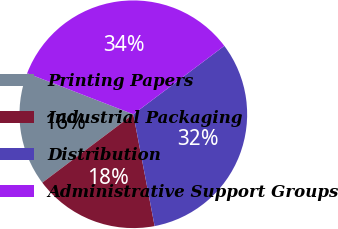Convert chart to OTSL. <chart><loc_0><loc_0><loc_500><loc_500><pie_chart><fcel>Printing Papers<fcel>Industrial Packaging<fcel>Distribution<fcel>Administrative Support Groups<nl><fcel>16.13%<fcel>17.74%<fcel>32.26%<fcel>33.87%<nl></chart> 